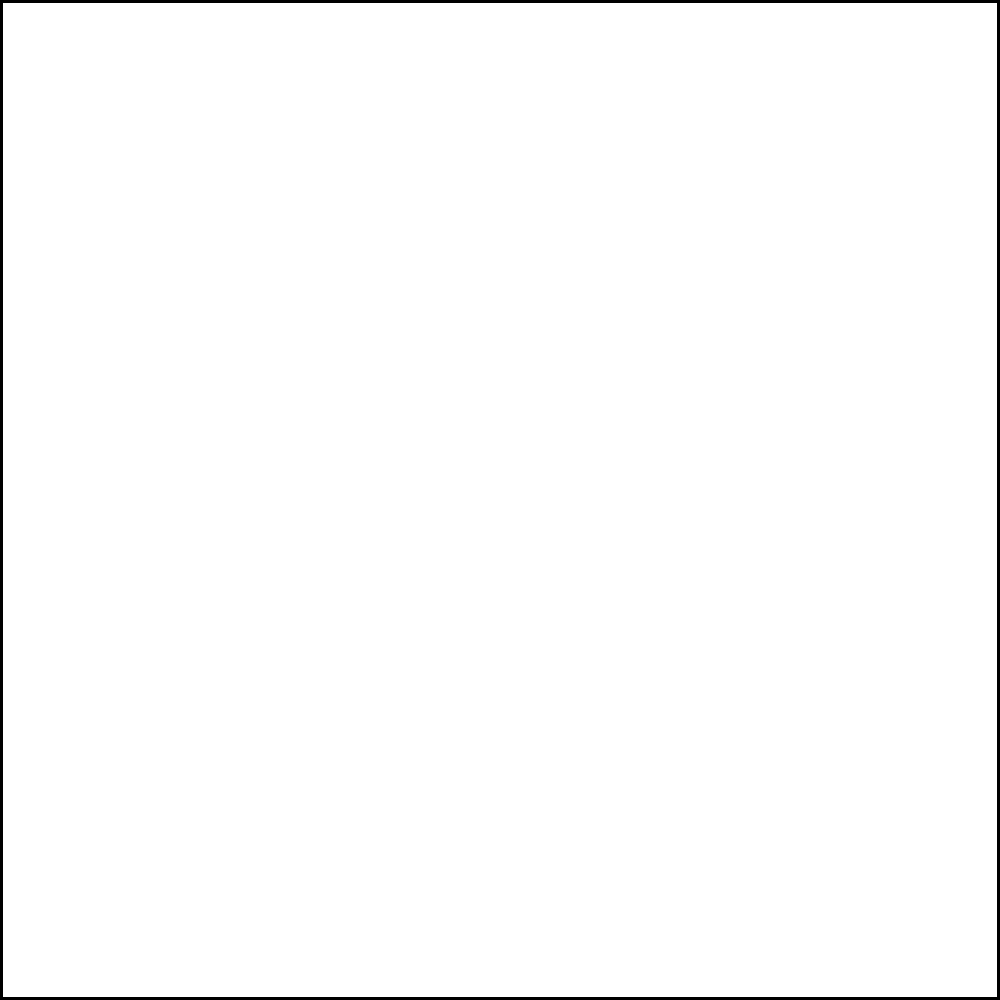In the mixing console layout shown, which combination of elements would best achieve a blend of ABBA-inspired sounds with contemporary pop production? To blend ABBA-inspired elements with contemporary pop sounds, we need to analyze the mixing console layout:

1. Identify ABBA-inspired elements:
   - Piano (fader 6): Raised to 80% (ABBA's iconic piano sound)
   - Strings (fader 7): Raised to 70% (ABBA's lush string arrangements)

2. Identify contemporary pop elements:
   - Drums (fader 2): Raised to 80% (modern, punchy beats)
   - Synth (fader 3): Raised to 70% (contemporary electronic sounds)

3. Consider other elements:
   - Bass (fader 1): At 50% (balanced foundation)
   - Vocals (fader 4): At 50% (can be adjusted based on the artist)
   - Guitar (fader 5): At 50% (can complement both styles)
   - Effects (fader 8): At 50% (can be used to enhance both vintage and modern sounds)

4. Blend analysis:
   - The raised levels of piano and strings capture ABBA's signature sound
   - The elevated drums and synth bring in the contemporary pop feel
   - Other elements at mid-level allow for flexibility in the mix

5. Conclusion:
   The optimal blend is achieved by emphasizing piano and strings for the ABBA influence, while boosting drums and synth for the contemporary pop sound.
Answer: Piano + Strings (ABBA) with Drums + Synth (contemporary) 